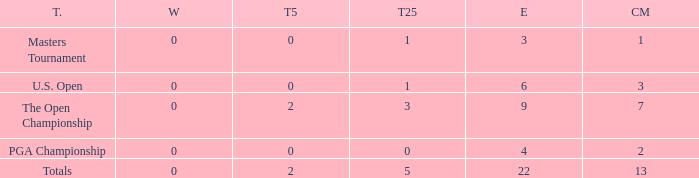What is the average number of cuts made for events with under 4 entries and more than 0 wins? None. 